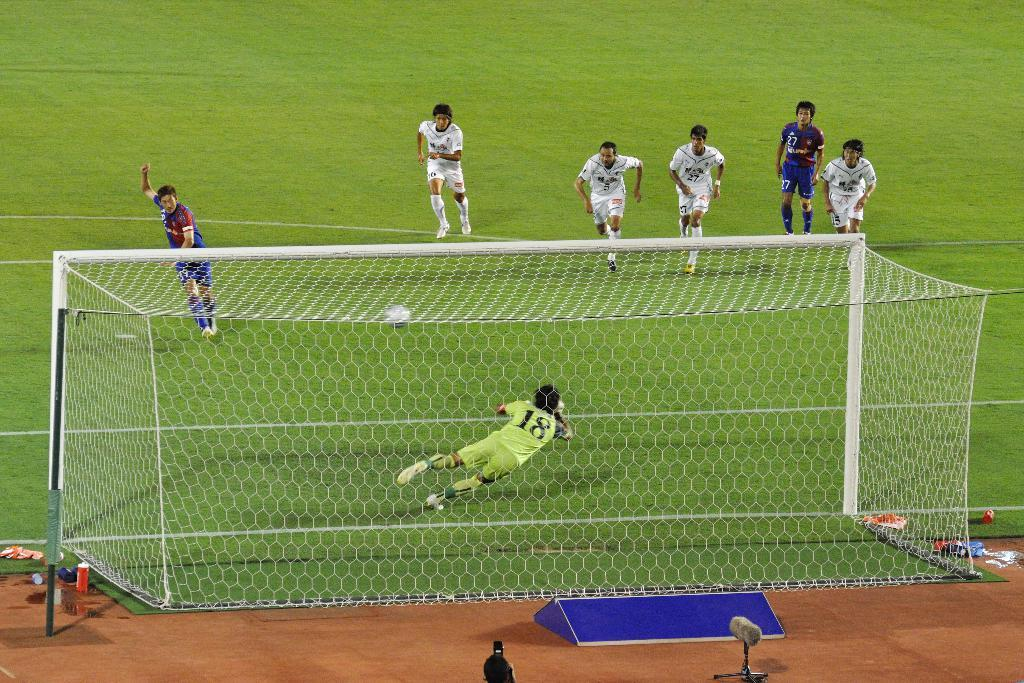<image>
Share a concise interpretation of the image provided. A soccer goalie, who wears jersey number 18, attempts to make a save. 